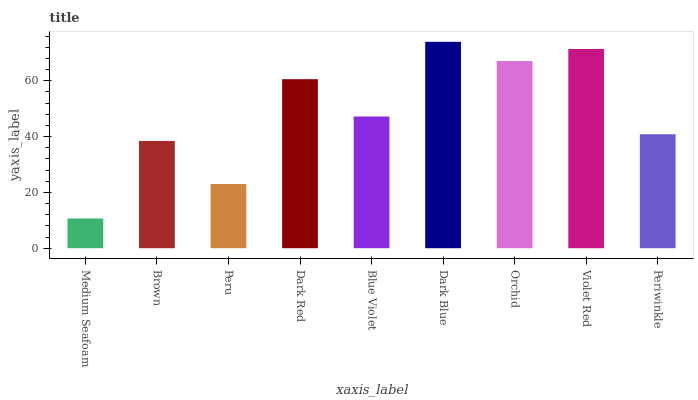Is Medium Seafoam the minimum?
Answer yes or no. Yes. Is Dark Blue the maximum?
Answer yes or no. Yes. Is Brown the minimum?
Answer yes or no. No. Is Brown the maximum?
Answer yes or no. No. Is Brown greater than Medium Seafoam?
Answer yes or no. Yes. Is Medium Seafoam less than Brown?
Answer yes or no. Yes. Is Medium Seafoam greater than Brown?
Answer yes or no. No. Is Brown less than Medium Seafoam?
Answer yes or no. No. Is Blue Violet the high median?
Answer yes or no. Yes. Is Blue Violet the low median?
Answer yes or no. Yes. Is Dark Blue the high median?
Answer yes or no. No. Is Orchid the low median?
Answer yes or no. No. 